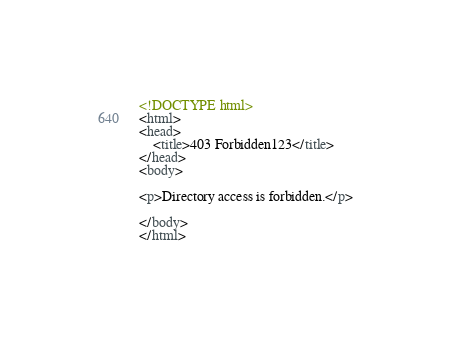<code> <loc_0><loc_0><loc_500><loc_500><_HTML_><!DOCTYPE html>
<html>
<head>
	<title>403 Forbidden123</title>
</head>
<body>

<p>Directory access is forbidden.</p>

</body>
</html>
</code> 